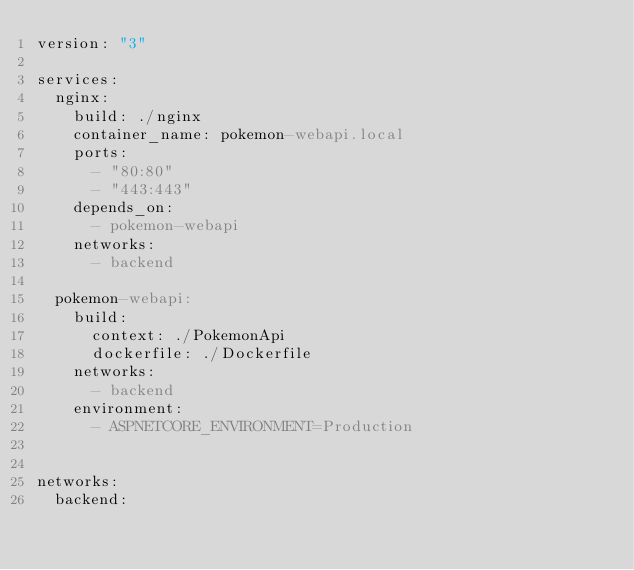Convert code to text. <code><loc_0><loc_0><loc_500><loc_500><_YAML_>version: "3"

services:
  nginx:
    build: ./nginx
    container_name: pokemon-webapi.local
    ports:
      - "80:80"
      - "443:443"
    depends_on:
      - pokemon-webapi
    networks:
      - backend

  pokemon-webapi:
    build:
      context: ./PokemonApi
      dockerfile: ./Dockerfile
    networks:
      - backend
    environment: 
      - ASPNETCORE_ENVIRONMENT=Production


networks:
  backend:</code> 